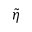<formula> <loc_0><loc_0><loc_500><loc_500>\tilde { \eta }</formula> 